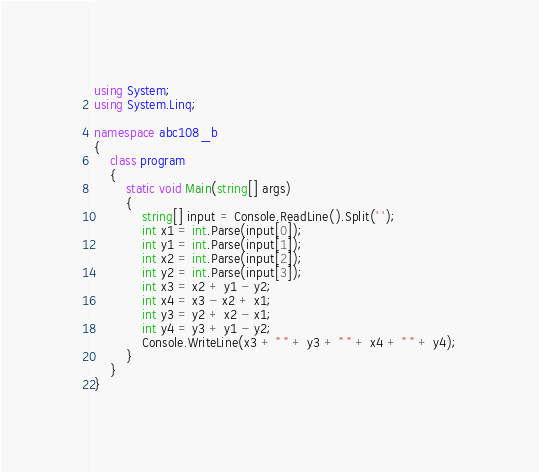Convert code to text. <code><loc_0><loc_0><loc_500><loc_500><_C#_>using System;
using System.Linq;

namespace abc108_b
{
    class program
    {
        static void Main(string[] args)
        {
            string[] input = Console.ReadLine().Split(' ');
            int x1 = int.Parse(input[0]);
            int y1 = int.Parse(input[1]);
            int x2 = int.Parse(input[2]);
            int y2 = int.Parse(input[3]);
            int x3 = x2 + y1 - y2;
            int x4 = x3 - x2 + x1;
            int y3 = y2 + x2 - x1;
            int y4 = y3 + y1 - y2;
            Console.WriteLine(x3 + " " + y3 + " " + x4 + " " + y4);
        }
    }
}</code> 